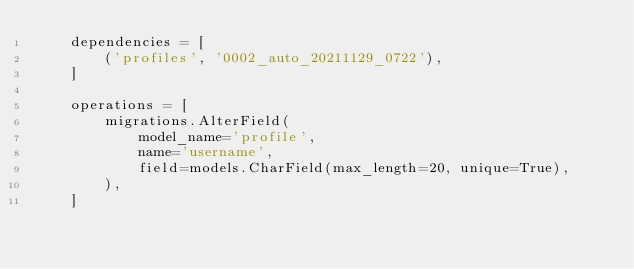<code> <loc_0><loc_0><loc_500><loc_500><_Python_>    dependencies = [
        ('profiles', '0002_auto_20211129_0722'),
    ]

    operations = [
        migrations.AlterField(
            model_name='profile',
            name='username',
            field=models.CharField(max_length=20, unique=True),
        ),
    ]
</code> 